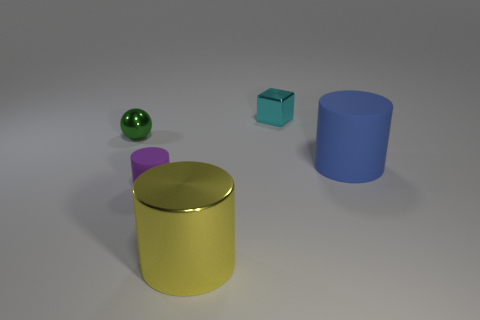There is a green metallic thing that is left of the small object in front of the small metal object left of the tiny purple matte cylinder; what is its size?
Make the answer very short. Small. What is the color of the shiny thing that is right of the metallic ball and behind the big matte cylinder?
Provide a succinct answer. Cyan. There is a purple rubber cylinder in front of the blue object; how big is it?
Provide a short and direct response. Small. How many cyan objects are the same material as the sphere?
Provide a short and direct response. 1. There is a small thing that is to the left of the small purple matte cylinder; is it the same shape as the small purple object?
Ensure brevity in your answer.  No. There is a block that is the same material as the ball; what color is it?
Your answer should be compact. Cyan. Are there any large blue rubber objects that are on the right side of the rubber cylinder that is to the right of the tiny metal object to the right of the small cylinder?
Offer a terse response. No. The tiny cyan thing has what shape?
Ensure brevity in your answer.  Cube. Is the number of yellow shiny cylinders behind the big blue rubber cylinder less than the number of small green objects?
Ensure brevity in your answer.  Yes. Are there any big blue metallic objects of the same shape as the small rubber thing?
Your response must be concise. No. 